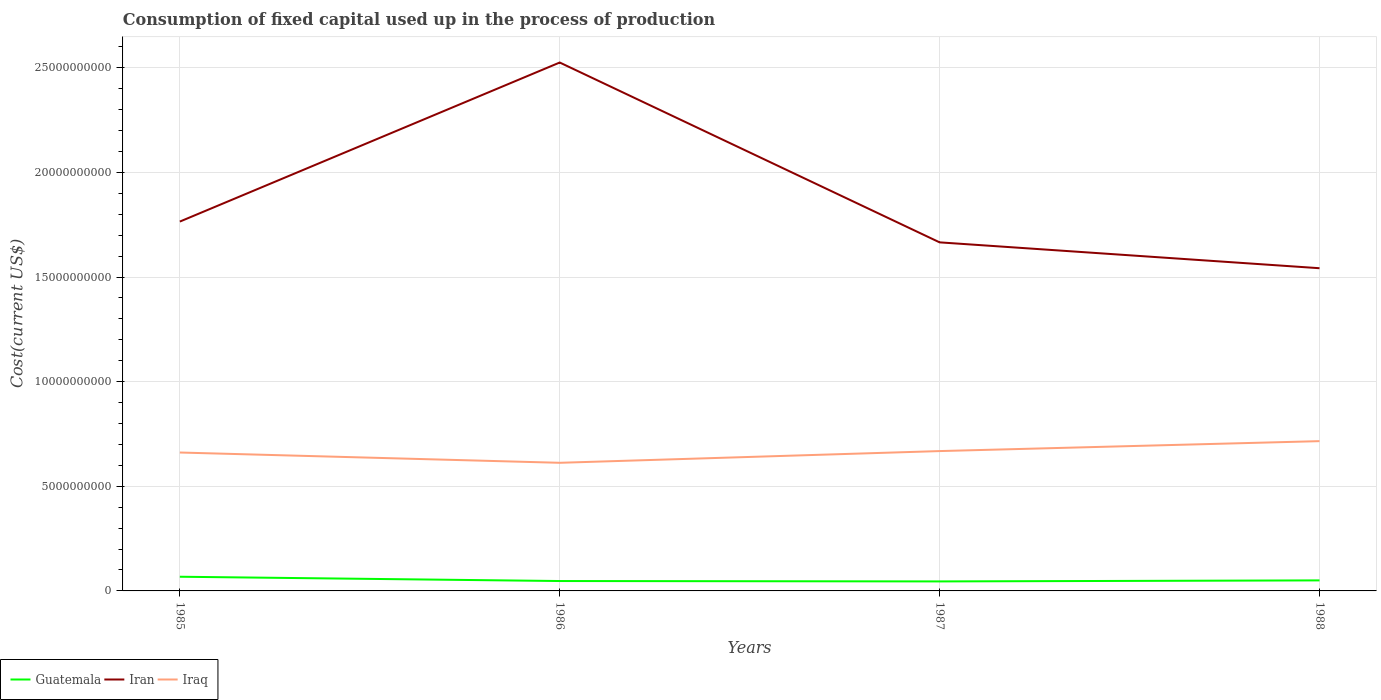Does the line corresponding to Guatemala intersect with the line corresponding to Iraq?
Ensure brevity in your answer.  No. Across all years, what is the maximum amount consumed in the process of production in Iran?
Ensure brevity in your answer.  1.54e+1. In which year was the amount consumed in the process of production in Iran maximum?
Make the answer very short. 1988. What is the total amount consumed in the process of production in Guatemala in the graph?
Offer a terse response. 1.88e+07. What is the difference between the highest and the second highest amount consumed in the process of production in Iran?
Keep it short and to the point. 9.83e+09. Is the amount consumed in the process of production in Iraq strictly greater than the amount consumed in the process of production in Guatemala over the years?
Make the answer very short. No. Does the graph contain any zero values?
Give a very brief answer. No. Does the graph contain grids?
Make the answer very short. Yes. How are the legend labels stacked?
Provide a succinct answer. Horizontal. What is the title of the graph?
Give a very brief answer. Consumption of fixed capital used up in the process of production. Does "Liechtenstein" appear as one of the legend labels in the graph?
Provide a short and direct response. No. What is the label or title of the X-axis?
Your answer should be very brief. Years. What is the label or title of the Y-axis?
Keep it short and to the point. Cost(current US$). What is the Cost(current US$) in Guatemala in 1985?
Make the answer very short. 6.78e+08. What is the Cost(current US$) in Iran in 1985?
Give a very brief answer. 1.77e+1. What is the Cost(current US$) in Iraq in 1985?
Provide a succinct answer. 6.61e+09. What is the Cost(current US$) of Guatemala in 1986?
Your answer should be very brief. 4.73e+08. What is the Cost(current US$) of Iran in 1986?
Your answer should be very brief. 2.53e+1. What is the Cost(current US$) of Iraq in 1986?
Your answer should be compact. 6.12e+09. What is the Cost(current US$) in Guatemala in 1987?
Your answer should be very brief. 4.54e+08. What is the Cost(current US$) in Iran in 1987?
Ensure brevity in your answer.  1.67e+1. What is the Cost(current US$) in Iraq in 1987?
Keep it short and to the point. 6.68e+09. What is the Cost(current US$) of Guatemala in 1988?
Your response must be concise. 5.03e+08. What is the Cost(current US$) in Iran in 1988?
Your response must be concise. 1.54e+1. What is the Cost(current US$) in Iraq in 1988?
Your response must be concise. 7.16e+09. Across all years, what is the maximum Cost(current US$) of Guatemala?
Offer a terse response. 6.78e+08. Across all years, what is the maximum Cost(current US$) in Iran?
Offer a terse response. 2.53e+1. Across all years, what is the maximum Cost(current US$) of Iraq?
Keep it short and to the point. 7.16e+09. Across all years, what is the minimum Cost(current US$) of Guatemala?
Ensure brevity in your answer.  4.54e+08. Across all years, what is the minimum Cost(current US$) in Iran?
Keep it short and to the point. 1.54e+1. Across all years, what is the minimum Cost(current US$) in Iraq?
Offer a terse response. 6.12e+09. What is the total Cost(current US$) in Guatemala in the graph?
Offer a very short reply. 2.11e+09. What is the total Cost(current US$) of Iran in the graph?
Make the answer very short. 7.50e+1. What is the total Cost(current US$) in Iraq in the graph?
Your answer should be compact. 2.66e+1. What is the difference between the Cost(current US$) in Guatemala in 1985 and that in 1986?
Make the answer very short. 2.05e+08. What is the difference between the Cost(current US$) in Iran in 1985 and that in 1986?
Provide a short and direct response. -7.60e+09. What is the difference between the Cost(current US$) in Iraq in 1985 and that in 1986?
Provide a short and direct response. 4.91e+08. What is the difference between the Cost(current US$) of Guatemala in 1985 and that in 1987?
Provide a succinct answer. 2.24e+08. What is the difference between the Cost(current US$) of Iran in 1985 and that in 1987?
Your response must be concise. 9.93e+08. What is the difference between the Cost(current US$) in Iraq in 1985 and that in 1987?
Ensure brevity in your answer.  -6.83e+07. What is the difference between the Cost(current US$) in Guatemala in 1985 and that in 1988?
Your response must be concise. 1.75e+08. What is the difference between the Cost(current US$) of Iran in 1985 and that in 1988?
Ensure brevity in your answer.  2.23e+09. What is the difference between the Cost(current US$) of Iraq in 1985 and that in 1988?
Ensure brevity in your answer.  -5.43e+08. What is the difference between the Cost(current US$) in Guatemala in 1986 and that in 1987?
Your answer should be compact. 1.88e+07. What is the difference between the Cost(current US$) of Iran in 1986 and that in 1987?
Provide a succinct answer. 8.59e+09. What is the difference between the Cost(current US$) in Iraq in 1986 and that in 1987?
Your response must be concise. -5.60e+08. What is the difference between the Cost(current US$) in Guatemala in 1986 and that in 1988?
Provide a short and direct response. -3.08e+07. What is the difference between the Cost(current US$) of Iran in 1986 and that in 1988?
Give a very brief answer. 9.83e+09. What is the difference between the Cost(current US$) in Iraq in 1986 and that in 1988?
Offer a very short reply. -1.03e+09. What is the difference between the Cost(current US$) of Guatemala in 1987 and that in 1988?
Give a very brief answer. -4.96e+07. What is the difference between the Cost(current US$) in Iran in 1987 and that in 1988?
Your answer should be compact. 1.24e+09. What is the difference between the Cost(current US$) of Iraq in 1987 and that in 1988?
Offer a very short reply. -4.75e+08. What is the difference between the Cost(current US$) in Guatemala in 1985 and the Cost(current US$) in Iran in 1986?
Make the answer very short. -2.46e+1. What is the difference between the Cost(current US$) in Guatemala in 1985 and the Cost(current US$) in Iraq in 1986?
Keep it short and to the point. -5.45e+09. What is the difference between the Cost(current US$) in Iran in 1985 and the Cost(current US$) in Iraq in 1986?
Give a very brief answer. 1.15e+1. What is the difference between the Cost(current US$) in Guatemala in 1985 and the Cost(current US$) in Iran in 1987?
Offer a terse response. -1.60e+1. What is the difference between the Cost(current US$) of Guatemala in 1985 and the Cost(current US$) of Iraq in 1987?
Your answer should be compact. -6.01e+09. What is the difference between the Cost(current US$) in Iran in 1985 and the Cost(current US$) in Iraq in 1987?
Ensure brevity in your answer.  1.10e+1. What is the difference between the Cost(current US$) of Guatemala in 1985 and the Cost(current US$) of Iran in 1988?
Keep it short and to the point. -1.47e+1. What is the difference between the Cost(current US$) of Guatemala in 1985 and the Cost(current US$) of Iraq in 1988?
Keep it short and to the point. -6.48e+09. What is the difference between the Cost(current US$) in Iran in 1985 and the Cost(current US$) in Iraq in 1988?
Offer a terse response. 1.05e+1. What is the difference between the Cost(current US$) in Guatemala in 1986 and the Cost(current US$) in Iran in 1987?
Provide a succinct answer. -1.62e+1. What is the difference between the Cost(current US$) in Guatemala in 1986 and the Cost(current US$) in Iraq in 1987?
Offer a very short reply. -6.21e+09. What is the difference between the Cost(current US$) of Iran in 1986 and the Cost(current US$) of Iraq in 1987?
Offer a terse response. 1.86e+1. What is the difference between the Cost(current US$) of Guatemala in 1986 and the Cost(current US$) of Iran in 1988?
Offer a very short reply. -1.49e+1. What is the difference between the Cost(current US$) of Guatemala in 1986 and the Cost(current US$) of Iraq in 1988?
Provide a succinct answer. -6.69e+09. What is the difference between the Cost(current US$) of Iran in 1986 and the Cost(current US$) of Iraq in 1988?
Provide a succinct answer. 1.81e+1. What is the difference between the Cost(current US$) of Guatemala in 1987 and the Cost(current US$) of Iran in 1988?
Offer a very short reply. -1.50e+1. What is the difference between the Cost(current US$) of Guatemala in 1987 and the Cost(current US$) of Iraq in 1988?
Offer a terse response. -6.70e+09. What is the difference between the Cost(current US$) in Iran in 1987 and the Cost(current US$) in Iraq in 1988?
Provide a short and direct response. 9.50e+09. What is the average Cost(current US$) of Guatemala per year?
Your response must be concise. 5.27e+08. What is the average Cost(current US$) in Iran per year?
Provide a short and direct response. 1.87e+1. What is the average Cost(current US$) of Iraq per year?
Provide a short and direct response. 6.64e+09. In the year 1985, what is the difference between the Cost(current US$) of Guatemala and Cost(current US$) of Iran?
Provide a succinct answer. -1.70e+1. In the year 1985, what is the difference between the Cost(current US$) of Guatemala and Cost(current US$) of Iraq?
Offer a very short reply. -5.94e+09. In the year 1985, what is the difference between the Cost(current US$) in Iran and Cost(current US$) in Iraq?
Make the answer very short. 1.10e+1. In the year 1986, what is the difference between the Cost(current US$) of Guatemala and Cost(current US$) of Iran?
Provide a succinct answer. -2.48e+1. In the year 1986, what is the difference between the Cost(current US$) of Guatemala and Cost(current US$) of Iraq?
Your answer should be compact. -5.65e+09. In the year 1986, what is the difference between the Cost(current US$) of Iran and Cost(current US$) of Iraq?
Make the answer very short. 1.91e+1. In the year 1987, what is the difference between the Cost(current US$) of Guatemala and Cost(current US$) of Iran?
Provide a succinct answer. -1.62e+1. In the year 1987, what is the difference between the Cost(current US$) of Guatemala and Cost(current US$) of Iraq?
Your answer should be compact. -6.23e+09. In the year 1987, what is the difference between the Cost(current US$) of Iran and Cost(current US$) of Iraq?
Ensure brevity in your answer.  9.97e+09. In the year 1988, what is the difference between the Cost(current US$) in Guatemala and Cost(current US$) in Iran?
Keep it short and to the point. -1.49e+1. In the year 1988, what is the difference between the Cost(current US$) of Guatemala and Cost(current US$) of Iraq?
Your answer should be very brief. -6.65e+09. In the year 1988, what is the difference between the Cost(current US$) in Iran and Cost(current US$) in Iraq?
Offer a terse response. 8.26e+09. What is the ratio of the Cost(current US$) of Guatemala in 1985 to that in 1986?
Keep it short and to the point. 1.43. What is the ratio of the Cost(current US$) in Iran in 1985 to that in 1986?
Keep it short and to the point. 0.7. What is the ratio of the Cost(current US$) in Iraq in 1985 to that in 1986?
Give a very brief answer. 1.08. What is the ratio of the Cost(current US$) in Guatemala in 1985 to that in 1987?
Offer a terse response. 1.49. What is the ratio of the Cost(current US$) in Iran in 1985 to that in 1987?
Your answer should be very brief. 1.06. What is the ratio of the Cost(current US$) in Iraq in 1985 to that in 1987?
Make the answer very short. 0.99. What is the ratio of the Cost(current US$) of Guatemala in 1985 to that in 1988?
Offer a terse response. 1.35. What is the ratio of the Cost(current US$) in Iran in 1985 to that in 1988?
Provide a short and direct response. 1.14. What is the ratio of the Cost(current US$) of Iraq in 1985 to that in 1988?
Make the answer very short. 0.92. What is the ratio of the Cost(current US$) of Guatemala in 1986 to that in 1987?
Your response must be concise. 1.04. What is the ratio of the Cost(current US$) of Iran in 1986 to that in 1987?
Provide a short and direct response. 1.52. What is the ratio of the Cost(current US$) in Iraq in 1986 to that in 1987?
Ensure brevity in your answer.  0.92. What is the ratio of the Cost(current US$) in Guatemala in 1986 to that in 1988?
Keep it short and to the point. 0.94. What is the ratio of the Cost(current US$) of Iran in 1986 to that in 1988?
Your answer should be compact. 1.64. What is the ratio of the Cost(current US$) in Iraq in 1986 to that in 1988?
Provide a succinct answer. 0.86. What is the ratio of the Cost(current US$) in Guatemala in 1987 to that in 1988?
Ensure brevity in your answer.  0.9. What is the ratio of the Cost(current US$) in Iran in 1987 to that in 1988?
Ensure brevity in your answer.  1.08. What is the ratio of the Cost(current US$) in Iraq in 1987 to that in 1988?
Keep it short and to the point. 0.93. What is the difference between the highest and the second highest Cost(current US$) in Guatemala?
Provide a succinct answer. 1.75e+08. What is the difference between the highest and the second highest Cost(current US$) of Iran?
Your answer should be very brief. 7.60e+09. What is the difference between the highest and the second highest Cost(current US$) in Iraq?
Your answer should be very brief. 4.75e+08. What is the difference between the highest and the lowest Cost(current US$) in Guatemala?
Keep it short and to the point. 2.24e+08. What is the difference between the highest and the lowest Cost(current US$) in Iran?
Make the answer very short. 9.83e+09. What is the difference between the highest and the lowest Cost(current US$) of Iraq?
Ensure brevity in your answer.  1.03e+09. 